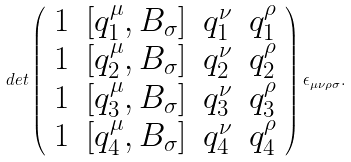<formula> <loc_0><loc_0><loc_500><loc_500>d e t \left ( \begin{array} { c c c c } 1 & [ q _ { 1 } ^ { \mu } , B _ { \sigma } ] & q ^ { \nu } _ { 1 } & q ^ { \rho } _ { 1 } \\ 1 & [ q _ { 2 } ^ { \mu } , B _ { \sigma } ] & q ^ { \nu } _ { 2 } & q ^ { \rho } _ { 2 } \\ 1 & [ q _ { 3 } ^ { \mu } , B _ { \sigma } ] & q ^ { \nu } _ { 3 } & q ^ { \rho } _ { 3 } \\ 1 & [ q _ { 4 } ^ { \mu } , B _ { \sigma } ] & q ^ { \nu } _ { 4 } & q ^ { \rho } _ { 4 } \\ \end{array} \right ) \epsilon _ { \mu \nu \rho \sigma } .</formula> 